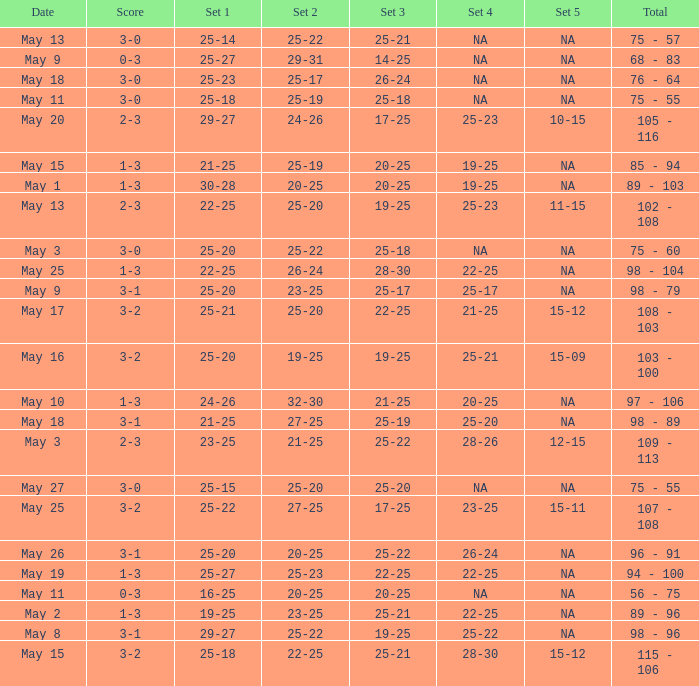What is the set 2 the has 1 set of 21-25, and 4 sets of 25-20? 27-25. 